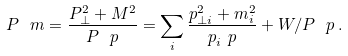<formula> <loc_0><loc_0><loc_500><loc_500>P ^ { \ } m = \frac { P _ { \perp } ^ { 2 } + M ^ { 2 } } { P ^ { \ } p } = \sum _ { i } \frac { p _ { \perp i } ^ { 2 } + m _ { i } ^ { 2 } } { p _ { i } ^ { \ } p } + W / P ^ { \ } p \, .</formula> 